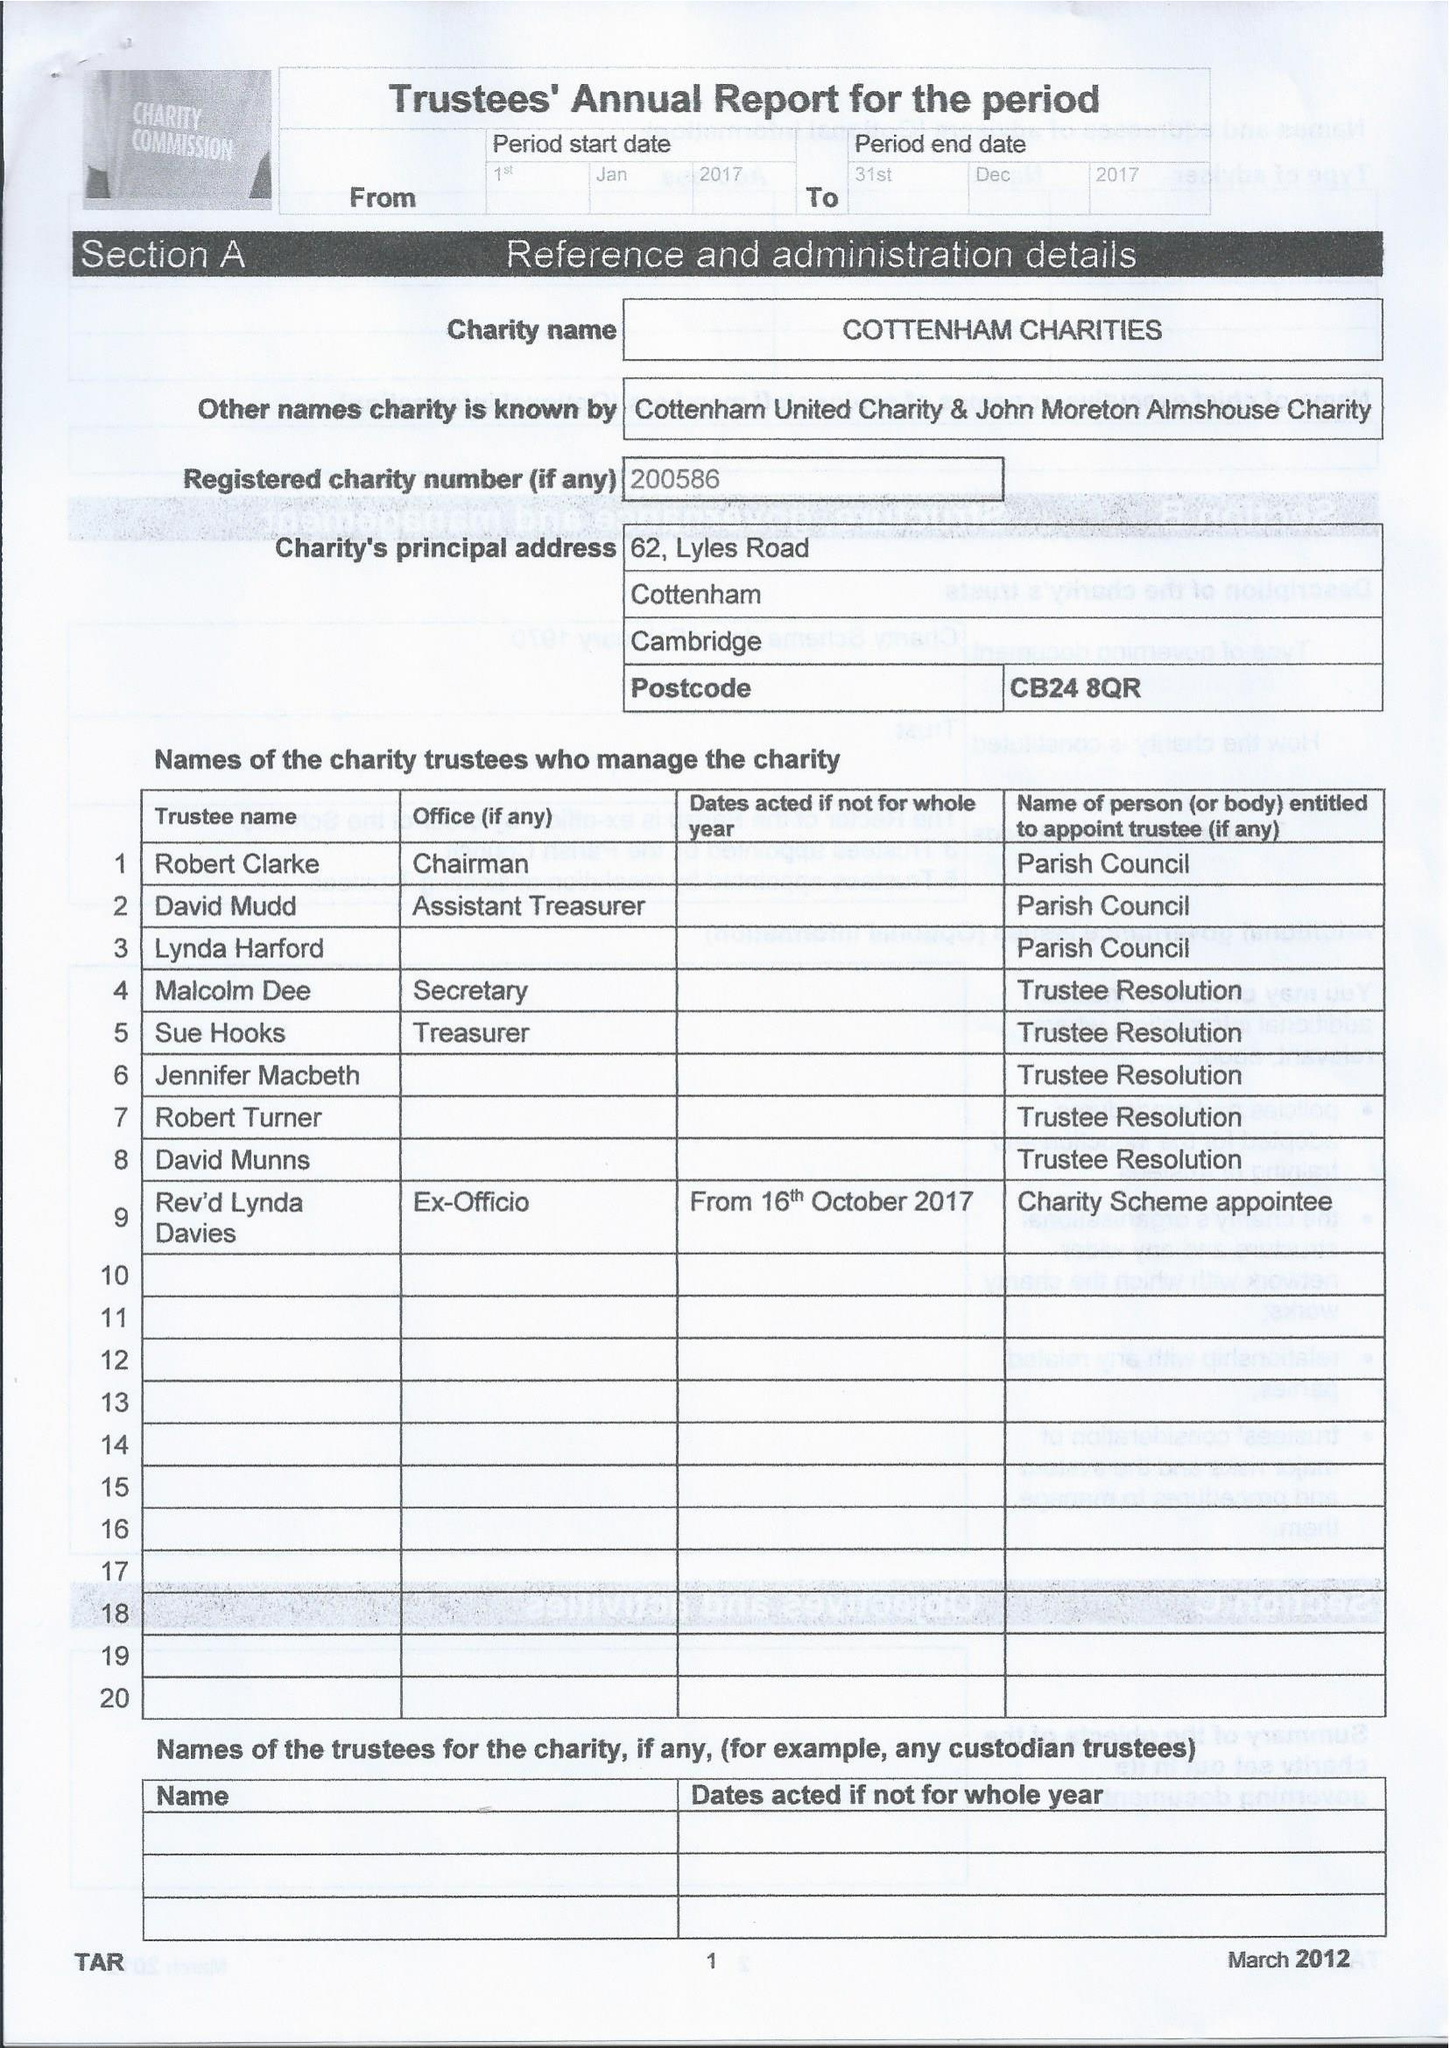What is the value for the charity_name?
Answer the question using a single word or phrase. Cottenham Charities 